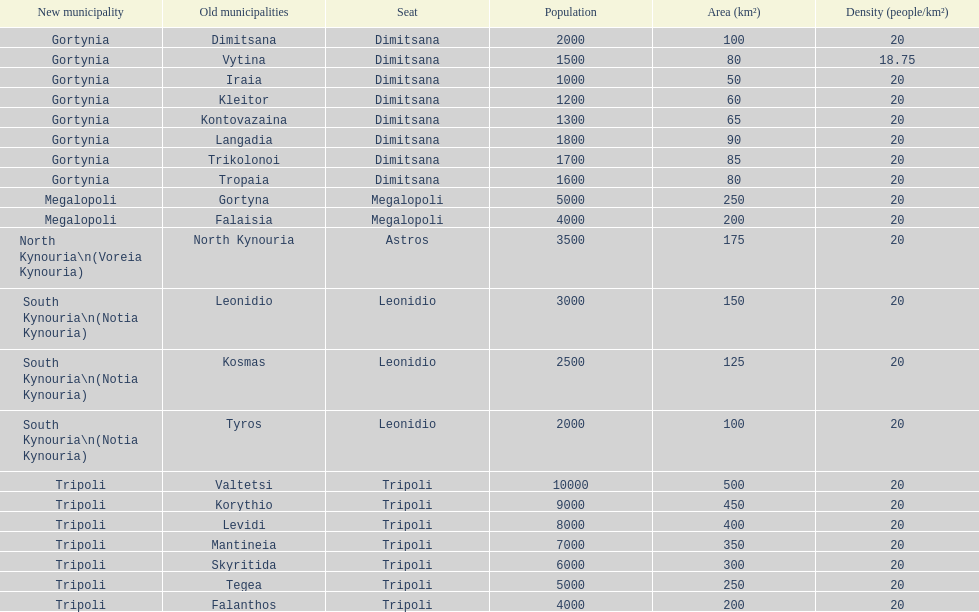What is the new municipality of tyros? South Kynouria. Help me parse the entirety of this table. {'header': ['New municipality', 'Old municipalities', 'Seat', 'Population', 'Area (km²)', 'Density (people/km²)'], 'rows': [['Gortynia', 'Dimitsana', 'Dimitsana', '2000', '100', '20'], ['Gortynia', 'Vytina', 'Dimitsana', '1500', '80', '18.75'], ['Gortynia', 'Iraia', 'Dimitsana', '1000', '50', '20'], ['Gortynia', 'Kleitor', 'Dimitsana', '1200', '60', '20'], ['Gortynia', 'Kontovazaina', 'Dimitsana', '1300', '65', '20'], ['Gortynia', 'Langadia', 'Dimitsana', '1800', '90', '20'], ['Gortynia', 'Trikolonoi', 'Dimitsana', '1700', '85', '20'], ['Gortynia', 'Tropaia', 'Dimitsana', '1600', '80', '20'], ['Megalopoli', 'Gortyna', 'Megalopoli', '5000', '250', '20'], ['Megalopoli', 'Falaisia', 'Megalopoli', '4000', '200', '20'], ['North Kynouria\\n(Voreia Kynouria)', 'North Kynouria', 'Astros', '3500', '175', '20'], ['South Kynouria\\n(Notia Kynouria)', 'Leonidio', 'Leonidio', '3000', '150', '20'], ['South Kynouria\\n(Notia Kynouria)', 'Kosmas', 'Leonidio', '2500', '125', '20'], ['South Kynouria\\n(Notia Kynouria)', 'Tyros', 'Leonidio', '2000', '100', '20'], ['Tripoli', 'Valtetsi', 'Tripoli', '10000', '500', '20'], ['Tripoli', 'Korythio', 'Tripoli', '9000', '450', '20'], ['Tripoli', 'Levidi', 'Tripoli', '8000', '400', '20'], ['Tripoli', 'Mantineia', 'Tripoli', '7000', '350', '20'], ['Tripoli', 'Skyritida', 'Tripoli', '6000', '300', '20'], ['Tripoli', 'Tegea', 'Tripoli', '5000', '250', '20'], ['Tripoli', 'Falanthos', 'Tripoli', '4000', '200', '20']]} 